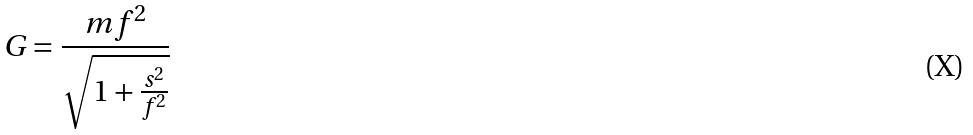<formula> <loc_0><loc_0><loc_500><loc_500>G = \frac { m f ^ { 2 } } { \sqrt { 1 + \frac { s ^ { 2 } } { f ^ { 2 } } } }</formula> 